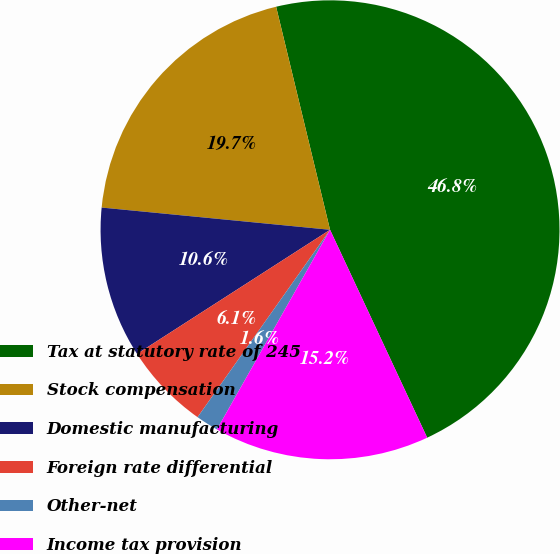<chart> <loc_0><loc_0><loc_500><loc_500><pie_chart><fcel>Tax at statutory rate of 245<fcel>Stock compensation<fcel>Domestic manufacturing<fcel>Foreign rate differential<fcel>Other-net<fcel>Income tax provision<nl><fcel>46.82%<fcel>19.68%<fcel>10.64%<fcel>6.11%<fcel>1.59%<fcel>15.16%<nl></chart> 